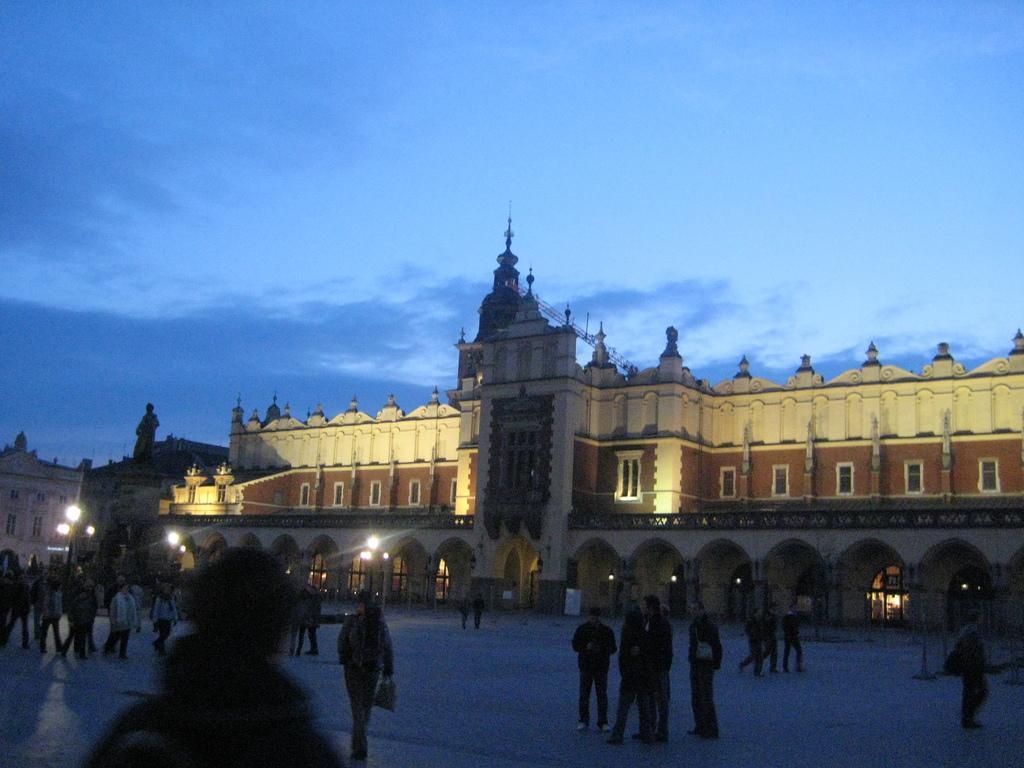Please provide a concise description of this image. In the image there is a palace and in front of the palace there is a pavement, there are many people on the pavement. 